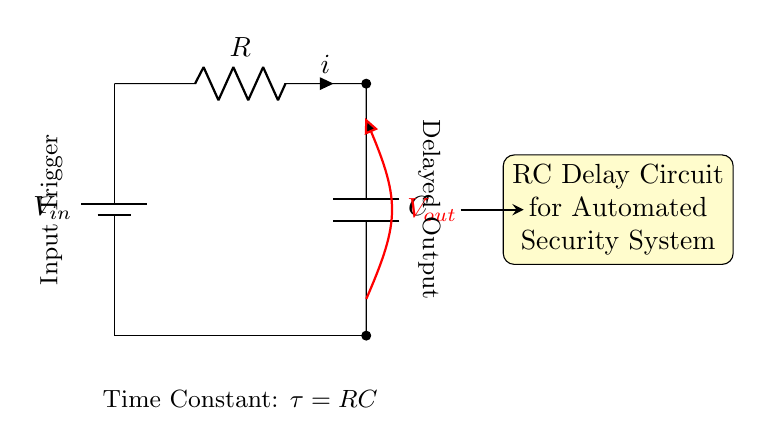What is the input voltage in this circuit? The input voltage is denoted as V_in, which indicates the power supplied to the circuit.
Answer: V_in What component is used to store energy in this circuit? The component that stores energy is the capacitor, indicated by the letter C in the diagram.
Answer: Capacitor What does the resistor in this circuit do? The resistor regulates the current flow and affects the time constant of the circuit, which determines how fast the capacitor charges or discharges.
Answer: Regulates current What is the output voltage defined as? The output voltage is represented as V_out and is measured across the capacitor in this configuration.
Answer: V_out What is the time constant of this RC circuit? The time constant τ is calculated using the formula τ = RC, which shows how long it takes for the capacitor to charge to approximately 63.2% of V_in.
Answer: RC How will the output change with a larger resistor value? A larger resistor will increase the time constant τ, resulting in a slower rise and fall of the output voltage over time.
Answer: Slower output What happens when the capacitor is fully charged in this circuit? When the capacitor is fully charged, the voltage across it equals V_in, and the current through the circuit drops to zero.
Answer: Voltage equals V_in 